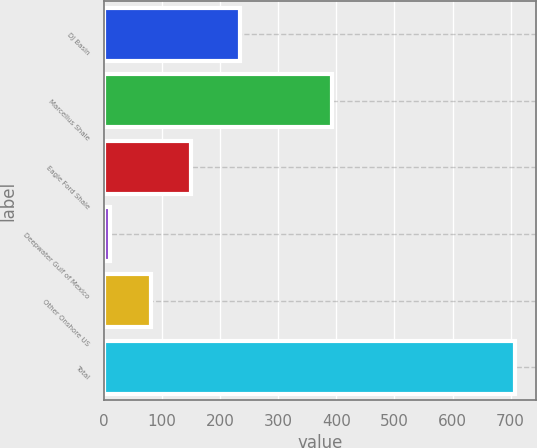Convert chart to OTSL. <chart><loc_0><loc_0><loc_500><loc_500><bar_chart><fcel>DJ Basin<fcel>Marcellus Shale<fcel>Eagle Ford Shale<fcel>Deepwater Gulf of Mexico<fcel>Other Onshore US<fcel>Total<nl><fcel>234<fcel>393<fcel>150.4<fcel>11<fcel>80.7<fcel>708<nl></chart> 